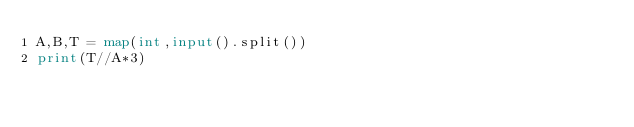Convert code to text. <code><loc_0><loc_0><loc_500><loc_500><_Python_>A,B,T = map(int,input().split())
print(T//A*3)</code> 